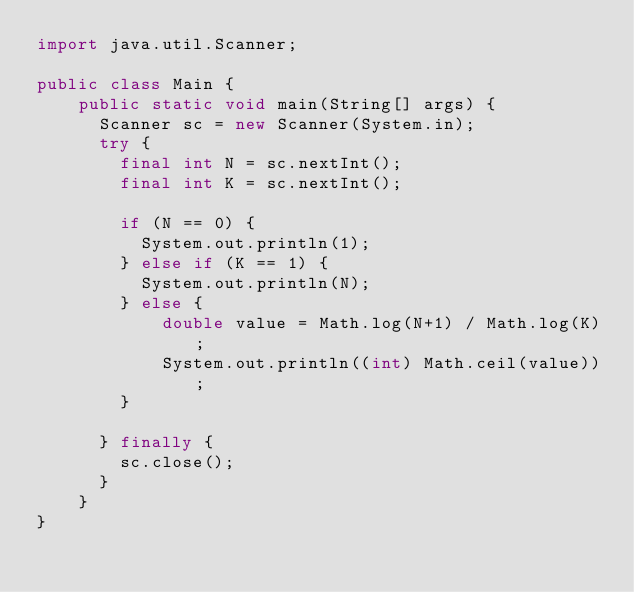<code> <loc_0><loc_0><loc_500><loc_500><_Java_>import java.util.Scanner;

public class Main {
    public static void main(String[] args) {
    	Scanner sc = new Scanner(System.in);
    	try {
    		final int N = sc.nextInt();
    		final int K = sc.nextInt();

    		if (N == 0) {
    			System.out.println(1);
    		} else if (K == 1) {
    			System.out.println(N);
    		} else {
        		double value = Math.log(N+1) / Math.log(K);
        		System.out.println((int) Math.ceil(value));
    		}

    	} finally {
    		sc.close();
    	}
    }
}
</code> 